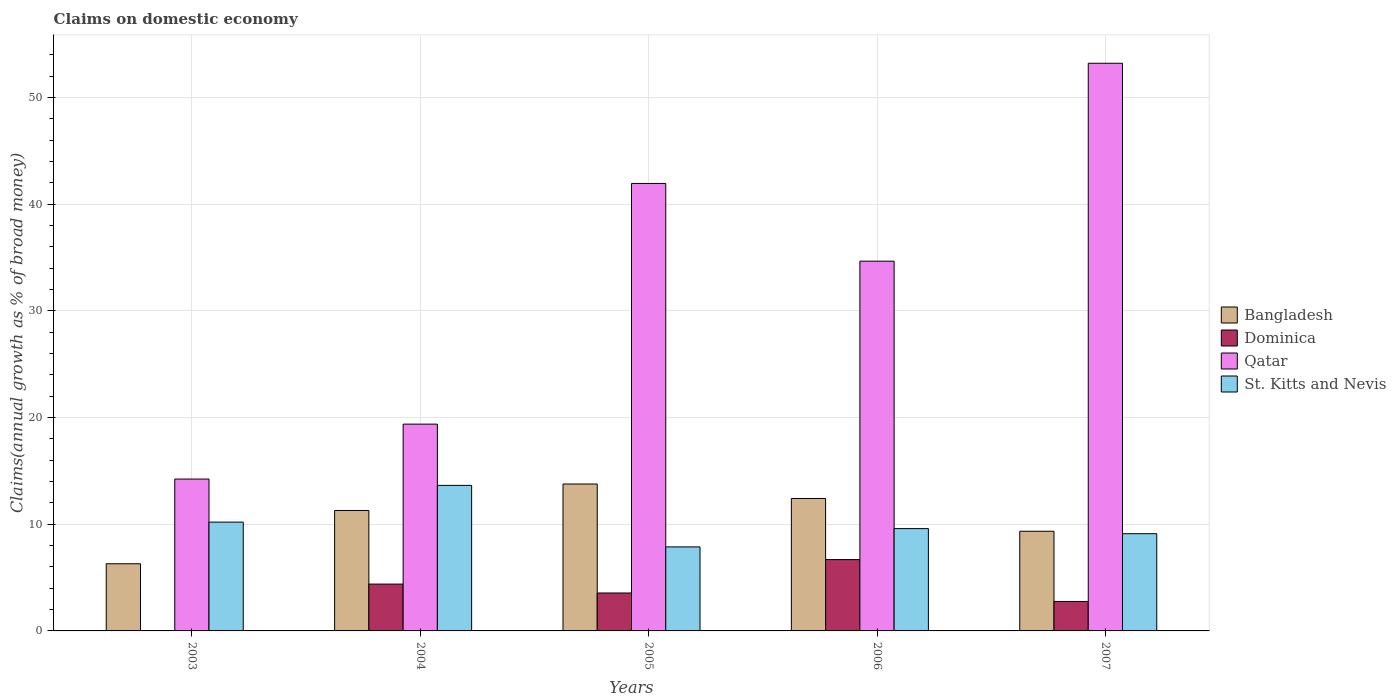How many different coloured bars are there?
Your answer should be compact. 4. How many groups of bars are there?
Provide a succinct answer. 5. Are the number of bars on each tick of the X-axis equal?
Your answer should be very brief. No. How many bars are there on the 1st tick from the left?
Keep it short and to the point. 3. How many bars are there on the 5th tick from the right?
Give a very brief answer. 3. Across all years, what is the maximum percentage of broad money claimed on domestic economy in Qatar?
Your answer should be compact. 53.22. Across all years, what is the minimum percentage of broad money claimed on domestic economy in Qatar?
Offer a very short reply. 14.24. In which year was the percentage of broad money claimed on domestic economy in Qatar maximum?
Your answer should be compact. 2007. What is the total percentage of broad money claimed on domestic economy in St. Kitts and Nevis in the graph?
Offer a very short reply. 50.43. What is the difference between the percentage of broad money claimed on domestic economy in Bangladesh in 2005 and that in 2007?
Ensure brevity in your answer.  4.43. What is the difference between the percentage of broad money claimed on domestic economy in Dominica in 2005 and the percentage of broad money claimed on domestic economy in Bangladesh in 2006?
Your response must be concise. -8.86. What is the average percentage of broad money claimed on domestic economy in Dominica per year?
Keep it short and to the point. 3.48. In the year 2007, what is the difference between the percentage of broad money claimed on domestic economy in Qatar and percentage of broad money claimed on domestic economy in Dominica?
Your response must be concise. 50.46. What is the ratio of the percentage of broad money claimed on domestic economy in Bangladesh in 2004 to that in 2006?
Your response must be concise. 0.91. What is the difference between the highest and the second highest percentage of broad money claimed on domestic economy in St. Kitts and Nevis?
Your answer should be compact. 3.44. What is the difference between the highest and the lowest percentage of broad money claimed on domestic economy in Bangladesh?
Provide a short and direct response. 7.48. Is it the case that in every year, the sum of the percentage of broad money claimed on domestic economy in Qatar and percentage of broad money claimed on domestic economy in Bangladesh is greater than the sum of percentage of broad money claimed on domestic economy in St. Kitts and Nevis and percentage of broad money claimed on domestic economy in Dominica?
Offer a terse response. Yes. Is it the case that in every year, the sum of the percentage of broad money claimed on domestic economy in St. Kitts and Nevis and percentage of broad money claimed on domestic economy in Bangladesh is greater than the percentage of broad money claimed on domestic economy in Qatar?
Your response must be concise. No. Are all the bars in the graph horizontal?
Provide a succinct answer. No. How many years are there in the graph?
Provide a short and direct response. 5. What is the difference between two consecutive major ticks on the Y-axis?
Give a very brief answer. 10. What is the title of the graph?
Your response must be concise. Claims on domestic economy. Does "Germany" appear as one of the legend labels in the graph?
Your response must be concise. No. What is the label or title of the Y-axis?
Your response must be concise. Claims(annual growth as % of broad money). What is the Claims(annual growth as % of broad money) in Bangladesh in 2003?
Make the answer very short. 6.3. What is the Claims(annual growth as % of broad money) in Dominica in 2003?
Provide a short and direct response. 0. What is the Claims(annual growth as % of broad money) of Qatar in 2003?
Your answer should be compact. 14.24. What is the Claims(annual growth as % of broad money) of St. Kitts and Nevis in 2003?
Give a very brief answer. 10.2. What is the Claims(annual growth as % of broad money) in Bangladesh in 2004?
Your answer should be very brief. 11.29. What is the Claims(annual growth as % of broad money) in Dominica in 2004?
Ensure brevity in your answer.  4.39. What is the Claims(annual growth as % of broad money) of Qatar in 2004?
Give a very brief answer. 19.39. What is the Claims(annual growth as % of broad money) of St. Kitts and Nevis in 2004?
Offer a very short reply. 13.65. What is the Claims(annual growth as % of broad money) of Bangladesh in 2005?
Provide a short and direct response. 13.77. What is the Claims(annual growth as % of broad money) of Dominica in 2005?
Offer a very short reply. 3.56. What is the Claims(annual growth as % of broad money) of Qatar in 2005?
Your answer should be very brief. 41.96. What is the Claims(annual growth as % of broad money) of St. Kitts and Nevis in 2005?
Your answer should be very brief. 7.88. What is the Claims(annual growth as % of broad money) in Bangladesh in 2006?
Offer a very short reply. 12.42. What is the Claims(annual growth as % of broad money) in Dominica in 2006?
Offer a very short reply. 6.69. What is the Claims(annual growth as % of broad money) in Qatar in 2006?
Ensure brevity in your answer.  34.67. What is the Claims(annual growth as % of broad money) of St. Kitts and Nevis in 2006?
Provide a succinct answer. 9.59. What is the Claims(annual growth as % of broad money) of Bangladesh in 2007?
Keep it short and to the point. 9.34. What is the Claims(annual growth as % of broad money) of Dominica in 2007?
Keep it short and to the point. 2.76. What is the Claims(annual growth as % of broad money) of Qatar in 2007?
Your answer should be very brief. 53.22. What is the Claims(annual growth as % of broad money) of St. Kitts and Nevis in 2007?
Your answer should be very brief. 9.12. Across all years, what is the maximum Claims(annual growth as % of broad money) in Bangladesh?
Your answer should be very brief. 13.77. Across all years, what is the maximum Claims(annual growth as % of broad money) in Dominica?
Offer a very short reply. 6.69. Across all years, what is the maximum Claims(annual growth as % of broad money) of Qatar?
Ensure brevity in your answer.  53.22. Across all years, what is the maximum Claims(annual growth as % of broad money) in St. Kitts and Nevis?
Keep it short and to the point. 13.65. Across all years, what is the minimum Claims(annual growth as % of broad money) in Bangladesh?
Offer a very short reply. 6.3. Across all years, what is the minimum Claims(annual growth as % of broad money) in Qatar?
Keep it short and to the point. 14.24. Across all years, what is the minimum Claims(annual growth as % of broad money) of St. Kitts and Nevis?
Give a very brief answer. 7.88. What is the total Claims(annual growth as % of broad money) in Bangladesh in the graph?
Ensure brevity in your answer.  53.13. What is the total Claims(annual growth as % of broad money) of Dominica in the graph?
Ensure brevity in your answer.  17.4. What is the total Claims(annual growth as % of broad money) of Qatar in the graph?
Your answer should be very brief. 163.48. What is the total Claims(annual growth as % of broad money) of St. Kitts and Nevis in the graph?
Ensure brevity in your answer.  50.43. What is the difference between the Claims(annual growth as % of broad money) in Bangladesh in 2003 and that in 2004?
Provide a short and direct response. -5. What is the difference between the Claims(annual growth as % of broad money) of Qatar in 2003 and that in 2004?
Your response must be concise. -5.15. What is the difference between the Claims(annual growth as % of broad money) of St. Kitts and Nevis in 2003 and that in 2004?
Your answer should be compact. -3.44. What is the difference between the Claims(annual growth as % of broad money) of Bangladesh in 2003 and that in 2005?
Ensure brevity in your answer.  -7.48. What is the difference between the Claims(annual growth as % of broad money) in Qatar in 2003 and that in 2005?
Your answer should be compact. -27.72. What is the difference between the Claims(annual growth as % of broad money) in St. Kitts and Nevis in 2003 and that in 2005?
Provide a short and direct response. 2.32. What is the difference between the Claims(annual growth as % of broad money) in Bangladesh in 2003 and that in 2006?
Provide a succinct answer. -6.12. What is the difference between the Claims(annual growth as % of broad money) of Qatar in 2003 and that in 2006?
Provide a succinct answer. -20.43. What is the difference between the Claims(annual growth as % of broad money) of St. Kitts and Nevis in 2003 and that in 2006?
Offer a terse response. 0.61. What is the difference between the Claims(annual growth as % of broad money) of Bangladesh in 2003 and that in 2007?
Provide a succinct answer. -3.05. What is the difference between the Claims(annual growth as % of broad money) in Qatar in 2003 and that in 2007?
Provide a short and direct response. -38.98. What is the difference between the Claims(annual growth as % of broad money) in St. Kitts and Nevis in 2003 and that in 2007?
Your response must be concise. 1.09. What is the difference between the Claims(annual growth as % of broad money) in Bangladesh in 2004 and that in 2005?
Make the answer very short. -2.48. What is the difference between the Claims(annual growth as % of broad money) of Dominica in 2004 and that in 2005?
Offer a terse response. 0.83. What is the difference between the Claims(annual growth as % of broad money) in Qatar in 2004 and that in 2005?
Ensure brevity in your answer.  -22.57. What is the difference between the Claims(annual growth as % of broad money) of St. Kitts and Nevis in 2004 and that in 2005?
Make the answer very short. 5.77. What is the difference between the Claims(annual growth as % of broad money) in Bangladesh in 2004 and that in 2006?
Your answer should be very brief. -1.13. What is the difference between the Claims(annual growth as % of broad money) in Dominica in 2004 and that in 2006?
Make the answer very short. -2.3. What is the difference between the Claims(annual growth as % of broad money) of Qatar in 2004 and that in 2006?
Provide a short and direct response. -15.28. What is the difference between the Claims(annual growth as % of broad money) in St. Kitts and Nevis in 2004 and that in 2006?
Your response must be concise. 4.05. What is the difference between the Claims(annual growth as % of broad money) in Bangladesh in 2004 and that in 2007?
Ensure brevity in your answer.  1.95. What is the difference between the Claims(annual growth as % of broad money) in Dominica in 2004 and that in 2007?
Provide a short and direct response. 1.63. What is the difference between the Claims(annual growth as % of broad money) of Qatar in 2004 and that in 2007?
Your answer should be compact. -33.84. What is the difference between the Claims(annual growth as % of broad money) of St. Kitts and Nevis in 2004 and that in 2007?
Your answer should be very brief. 4.53. What is the difference between the Claims(annual growth as % of broad money) of Bangladesh in 2005 and that in 2006?
Your response must be concise. 1.36. What is the difference between the Claims(annual growth as % of broad money) in Dominica in 2005 and that in 2006?
Offer a very short reply. -3.13. What is the difference between the Claims(annual growth as % of broad money) of Qatar in 2005 and that in 2006?
Give a very brief answer. 7.29. What is the difference between the Claims(annual growth as % of broad money) of St. Kitts and Nevis in 2005 and that in 2006?
Give a very brief answer. -1.71. What is the difference between the Claims(annual growth as % of broad money) of Bangladesh in 2005 and that in 2007?
Keep it short and to the point. 4.43. What is the difference between the Claims(annual growth as % of broad money) in Dominica in 2005 and that in 2007?
Provide a short and direct response. 0.8. What is the difference between the Claims(annual growth as % of broad money) of Qatar in 2005 and that in 2007?
Ensure brevity in your answer.  -11.27. What is the difference between the Claims(annual growth as % of broad money) in St. Kitts and Nevis in 2005 and that in 2007?
Your response must be concise. -1.24. What is the difference between the Claims(annual growth as % of broad money) of Bangladesh in 2006 and that in 2007?
Your answer should be compact. 3.07. What is the difference between the Claims(annual growth as % of broad money) of Dominica in 2006 and that in 2007?
Your response must be concise. 3.93. What is the difference between the Claims(annual growth as % of broad money) of Qatar in 2006 and that in 2007?
Your response must be concise. -18.56. What is the difference between the Claims(annual growth as % of broad money) in St. Kitts and Nevis in 2006 and that in 2007?
Offer a very short reply. 0.47. What is the difference between the Claims(annual growth as % of broad money) in Bangladesh in 2003 and the Claims(annual growth as % of broad money) in Dominica in 2004?
Keep it short and to the point. 1.91. What is the difference between the Claims(annual growth as % of broad money) in Bangladesh in 2003 and the Claims(annual growth as % of broad money) in Qatar in 2004?
Provide a short and direct response. -13.09. What is the difference between the Claims(annual growth as % of broad money) in Bangladesh in 2003 and the Claims(annual growth as % of broad money) in St. Kitts and Nevis in 2004?
Make the answer very short. -7.35. What is the difference between the Claims(annual growth as % of broad money) of Qatar in 2003 and the Claims(annual growth as % of broad money) of St. Kitts and Nevis in 2004?
Keep it short and to the point. 0.6. What is the difference between the Claims(annual growth as % of broad money) in Bangladesh in 2003 and the Claims(annual growth as % of broad money) in Dominica in 2005?
Offer a terse response. 2.74. What is the difference between the Claims(annual growth as % of broad money) of Bangladesh in 2003 and the Claims(annual growth as % of broad money) of Qatar in 2005?
Keep it short and to the point. -35.66. What is the difference between the Claims(annual growth as % of broad money) of Bangladesh in 2003 and the Claims(annual growth as % of broad money) of St. Kitts and Nevis in 2005?
Your answer should be very brief. -1.58. What is the difference between the Claims(annual growth as % of broad money) of Qatar in 2003 and the Claims(annual growth as % of broad money) of St. Kitts and Nevis in 2005?
Provide a succinct answer. 6.36. What is the difference between the Claims(annual growth as % of broad money) in Bangladesh in 2003 and the Claims(annual growth as % of broad money) in Dominica in 2006?
Ensure brevity in your answer.  -0.39. What is the difference between the Claims(annual growth as % of broad money) of Bangladesh in 2003 and the Claims(annual growth as % of broad money) of Qatar in 2006?
Provide a short and direct response. -28.37. What is the difference between the Claims(annual growth as % of broad money) of Bangladesh in 2003 and the Claims(annual growth as % of broad money) of St. Kitts and Nevis in 2006?
Provide a short and direct response. -3.29. What is the difference between the Claims(annual growth as % of broad money) of Qatar in 2003 and the Claims(annual growth as % of broad money) of St. Kitts and Nevis in 2006?
Your response must be concise. 4.65. What is the difference between the Claims(annual growth as % of broad money) of Bangladesh in 2003 and the Claims(annual growth as % of broad money) of Dominica in 2007?
Your answer should be compact. 3.54. What is the difference between the Claims(annual growth as % of broad money) in Bangladesh in 2003 and the Claims(annual growth as % of broad money) in Qatar in 2007?
Offer a very short reply. -46.93. What is the difference between the Claims(annual growth as % of broad money) of Bangladesh in 2003 and the Claims(annual growth as % of broad money) of St. Kitts and Nevis in 2007?
Offer a terse response. -2.82. What is the difference between the Claims(annual growth as % of broad money) in Qatar in 2003 and the Claims(annual growth as % of broad money) in St. Kitts and Nevis in 2007?
Provide a succinct answer. 5.12. What is the difference between the Claims(annual growth as % of broad money) in Bangladesh in 2004 and the Claims(annual growth as % of broad money) in Dominica in 2005?
Your answer should be compact. 7.74. What is the difference between the Claims(annual growth as % of broad money) of Bangladesh in 2004 and the Claims(annual growth as % of broad money) of Qatar in 2005?
Keep it short and to the point. -30.66. What is the difference between the Claims(annual growth as % of broad money) of Bangladesh in 2004 and the Claims(annual growth as % of broad money) of St. Kitts and Nevis in 2005?
Ensure brevity in your answer.  3.41. What is the difference between the Claims(annual growth as % of broad money) in Dominica in 2004 and the Claims(annual growth as % of broad money) in Qatar in 2005?
Offer a terse response. -37.56. What is the difference between the Claims(annual growth as % of broad money) in Dominica in 2004 and the Claims(annual growth as % of broad money) in St. Kitts and Nevis in 2005?
Make the answer very short. -3.49. What is the difference between the Claims(annual growth as % of broad money) in Qatar in 2004 and the Claims(annual growth as % of broad money) in St. Kitts and Nevis in 2005?
Your answer should be compact. 11.51. What is the difference between the Claims(annual growth as % of broad money) in Bangladesh in 2004 and the Claims(annual growth as % of broad money) in Dominica in 2006?
Your answer should be very brief. 4.6. What is the difference between the Claims(annual growth as % of broad money) in Bangladesh in 2004 and the Claims(annual growth as % of broad money) in Qatar in 2006?
Ensure brevity in your answer.  -23.38. What is the difference between the Claims(annual growth as % of broad money) of Bangladesh in 2004 and the Claims(annual growth as % of broad money) of St. Kitts and Nevis in 2006?
Your answer should be very brief. 1.7. What is the difference between the Claims(annual growth as % of broad money) of Dominica in 2004 and the Claims(annual growth as % of broad money) of Qatar in 2006?
Make the answer very short. -30.28. What is the difference between the Claims(annual growth as % of broad money) of Dominica in 2004 and the Claims(annual growth as % of broad money) of St. Kitts and Nevis in 2006?
Make the answer very short. -5.2. What is the difference between the Claims(annual growth as % of broad money) in Qatar in 2004 and the Claims(annual growth as % of broad money) in St. Kitts and Nevis in 2006?
Provide a succinct answer. 9.8. What is the difference between the Claims(annual growth as % of broad money) of Bangladesh in 2004 and the Claims(annual growth as % of broad money) of Dominica in 2007?
Offer a very short reply. 8.53. What is the difference between the Claims(annual growth as % of broad money) of Bangladesh in 2004 and the Claims(annual growth as % of broad money) of Qatar in 2007?
Keep it short and to the point. -41.93. What is the difference between the Claims(annual growth as % of broad money) of Bangladesh in 2004 and the Claims(annual growth as % of broad money) of St. Kitts and Nevis in 2007?
Keep it short and to the point. 2.18. What is the difference between the Claims(annual growth as % of broad money) of Dominica in 2004 and the Claims(annual growth as % of broad money) of Qatar in 2007?
Offer a very short reply. -48.83. What is the difference between the Claims(annual growth as % of broad money) of Dominica in 2004 and the Claims(annual growth as % of broad money) of St. Kitts and Nevis in 2007?
Your answer should be compact. -4.73. What is the difference between the Claims(annual growth as % of broad money) in Qatar in 2004 and the Claims(annual growth as % of broad money) in St. Kitts and Nevis in 2007?
Give a very brief answer. 10.27. What is the difference between the Claims(annual growth as % of broad money) of Bangladesh in 2005 and the Claims(annual growth as % of broad money) of Dominica in 2006?
Ensure brevity in your answer.  7.09. What is the difference between the Claims(annual growth as % of broad money) of Bangladesh in 2005 and the Claims(annual growth as % of broad money) of Qatar in 2006?
Make the answer very short. -20.89. What is the difference between the Claims(annual growth as % of broad money) of Bangladesh in 2005 and the Claims(annual growth as % of broad money) of St. Kitts and Nevis in 2006?
Offer a terse response. 4.18. What is the difference between the Claims(annual growth as % of broad money) in Dominica in 2005 and the Claims(annual growth as % of broad money) in Qatar in 2006?
Your answer should be compact. -31.11. What is the difference between the Claims(annual growth as % of broad money) of Dominica in 2005 and the Claims(annual growth as % of broad money) of St. Kitts and Nevis in 2006?
Your response must be concise. -6.03. What is the difference between the Claims(annual growth as % of broad money) of Qatar in 2005 and the Claims(annual growth as % of broad money) of St. Kitts and Nevis in 2006?
Make the answer very short. 32.36. What is the difference between the Claims(annual growth as % of broad money) in Bangladesh in 2005 and the Claims(annual growth as % of broad money) in Dominica in 2007?
Provide a short and direct response. 11.01. What is the difference between the Claims(annual growth as % of broad money) of Bangladesh in 2005 and the Claims(annual growth as % of broad money) of Qatar in 2007?
Give a very brief answer. -39.45. What is the difference between the Claims(annual growth as % of broad money) of Bangladesh in 2005 and the Claims(annual growth as % of broad money) of St. Kitts and Nevis in 2007?
Your answer should be very brief. 4.66. What is the difference between the Claims(annual growth as % of broad money) in Dominica in 2005 and the Claims(annual growth as % of broad money) in Qatar in 2007?
Offer a terse response. -49.67. What is the difference between the Claims(annual growth as % of broad money) of Dominica in 2005 and the Claims(annual growth as % of broad money) of St. Kitts and Nevis in 2007?
Keep it short and to the point. -5.56. What is the difference between the Claims(annual growth as % of broad money) of Qatar in 2005 and the Claims(annual growth as % of broad money) of St. Kitts and Nevis in 2007?
Your answer should be very brief. 32.84. What is the difference between the Claims(annual growth as % of broad money) in Bangladesh in 2006 and the Claims(annual growth as % of broad money) in Dominica in 2007?
Provide a succinct answer. 9.66. What is the difference between the Claims(annual growth as % of broad money) in Bangladesh in 2006 and the Claims(annual growth as % of broad money) in Qatar in 2007?
Provide a succinct answer. -40.81. What is the difference between the Claims(annual growth as % of broad money) of Bangladesh in 2006 and the Claims(annual growth as % of broad money) of St. Kitts and Nevis in 2007?
Your answer should be compact. 3.3. What is the difference between the Claims(annual growth as % of broad money) of Dominica in 2006 and the Claims(annual growth as % of broad money) of Qatar in 2007?
Your answer should be compact. -46.54. What is the difference between the Claims(annual growth as % of broad money) of Dominica in 2006 and the Claims(annual growth as % of broad money) of St. Kitts and Nevis in 2007?
Your response must be concise. -2.43. What is the difference between the Claims(annual growth as % of broad money) in Qatar in 2006 and the Claims(annual growth as % of broad money) in St. Kitts and Nevis in 2007?
Your answer should be very brief. 25.55. What is the average Claims(annual growth as % of broad money) in Bangladesh per year?
Your answer should be compact. 10.63. What is the average Claims(annual growth as % of broad money) in Dominica per year?
Offer a terse response. 3.48. What is the average Claims(annual growth as % of broad money) of Qatar per year?
Your response must be concise. 32.7. What is the average Claims(annual growth as % of broad money) in St. Kitts and Nevis per year?
Your answer should be compact. 10.09. In the year 2003, what is the difference between the Claims(annual growth as % of broad money) of Bangladesh and Claims(annual growth as % of broad money) of Qatar?
Your answer should be compact. -7.94. In the year 2003, what is the difference between the Claims(annual growth as % of broad money) of Bangladesh and Claims(annual growth as % of broad money) of St. Kitts and Nevis?
Give a very brief answer. -3.9. In the year 2003, what is the difference between the Claims(annual growth as % of broad money) in Qatar and Claims(annual growth as % of broad money) in St. Kitts and Nevis?
Your answer should be compact. 4.04. In the year 2004, what is the difference between the Claims(annual growth as % of broad money) in Bangladesh and Claims(annual growth as % of broad money) in Dominica?
Ensure brevity in your answer.  6.9. In the year 2004, what is the difference between the Claims(annual growth as % of broad money) in Bangladesh and Claims(annual growth as % of broad money) in Qatar?
Your answer should be very brief. -8.1. In the year 2004, what is the difference between the Claims(annual growth as % of broad money) in Bangladesh and Claims(annual growth as % of broad money) in St. Kitts and Nevis?
Your response must be concise. -2.35. In the year 2004, what is the difference between the Claims(annual growth as % of broad money) of Dominica and Claims(annual growth as % of broad money) of Qatar?
Ensure brevity in your answer.  -15. In the year 2004, what is the difference between the Claims(annual growth as % of broad money) of Dominica and Claims(annual growth as % of broad money) of St. Kitts and Nevis?
Make the answer very short. -9.25. In the year 2004, what is the difference between the Claims(annual growth as % of broad money) of Qatar and Claims(annual growth as % of broad money) of St. Kitts and Nevis?
Give a very brief answer. 5.74. In the year 2005, what is the difference between the Claims(annual growth as % of broad money) of Bangladesh and Claims(annual growth as % of broad money) of Dominica?
Make the answer very short. 10.22. In the year 2005, what is the difference between the Claims(annual growth as % of broad money) in Bangladesh and Claims(annual growth as % of broad money) in Qatar?
Provide a short and direct response. -28.18. In the year 2005, what is the difference between the Claims(annual growth as % of broad money) in Bangladesh and Claims(annual growth as % of broad money) in St. Kitts and Nevis?
Offer a terse response. 5.9. In the year 2005, what is the difference between the Claims(annual growth as % of broad money) in Dominica and Claims(annual growth as % of broad money) in Qatar?
Provide a short and direct response. -38.4. In the year 2005, what is the difference between the Claims(annual growth as % of broad money) in Dominica and Claims(annual growth as % of broad money) in St. Kitts and Nevis?
Offer a terse response. -4.32. In the year 2005, what is the difference between the Claims(annual growth as % of broad money) in Qatar and Claims(annual growth as % of broad money) in St. Kitts and Nevis?
Your response must be concise. 34.08. In the year 2006, what is the difference between the Claims(annual growth as % of broad money) of Bangladesh and Claims(annual growth as % of broad money) of Dominica?
Provide a succinct answer. 5.73. In the year 2006, what is the difference between the Claims(annual growth as % of broad money) of Bangladesh and Claims(annual growth as % of broad money) of Qatar?
Your answer should be very brief. -22.25. In the year 2006, what is the difference between the Claims(annual growth as % of broad money) in Bangladesh and Claims(annual growth as % of broad money) in St. Kitts and Nevis?
Give a very brief answer. 2.83. In the year 2006, what is the difference between the Claims(annual growth as % of broad money) in Dominica and Claims(annual growth as % of broad money) in Qatar?
Your answer should be very brief. -27.98. In the year 2006, what is the difference between the Claims(annual growth as % of broad money) of Dominica and Claims(annual growth as % of broad money) of St. Kitts and Nevis?
Give a very brief answer. -2.9. In the year 2006, what is the difference between the Claims(annual growth as % of broad money) of Qatar and Claims(annual growth as % of broad money) of St. Kitts and Nevis?
Your answer should be very brief. 25.08. In the year 2007, what is the difference between the Claims(annual growth as % of broad money) of Bangladesh and Claims(annual growth as % of broad money) of Dominica?
Ensure brevity in your answer.  6.58. In the year 2007, what is the difference between the Claims(annual growth as % of broad money) in Bangladesh and Claims(annual growth as % of broad money) in Qatar?
Ensure brevity in your answer.  -43.88. In the year 2007, what is the difference between the Claims(annual growth as % of broad money) in Bangladesh and Claims(annual growth as % of broad money) in St. Kitts and Nevis?
Offer a terse response. 0.23. In the year 2007, what is the difference between the Claims(annual growth as % of broad money) in Dominica and Claims(annual growth as % of broad money) in Qatar?
Provide a succinct answer. -50.46. In the year 2007, what is the difference between the Claims(annual growth as % of broad money) of Dominica and Claims(annual growth as % of broad money) of St. Kitts and Nevis?
Give a very brief answer. -6.35. In the year 2007, what is the difference between the Claims(annual growth as % of broad money) of Qatar and Claims(annual growth as % of broad money) of St. Kitts and Nevis?
Provide a succinct answer. 44.11. What is the ratio of the Claims(annual growth as % of broad money) of Bangladesh in 2003 to that in 2004?
Ensure brevity in your answer.  0.56. What is the ratio of the Claims(annual growth as % of broad money) in Qatar in 2003 to that in 2004?
Provide a short and direct response. 0.73. What is the ratio of the Claims(annual growth as % of broad money) of St. Kitts and Nevis in 2003 to that in 2004?
Ensure brevity in your answer.  0.75. What is the ratio of the Claims(annual growth as % of broad money) in Bangladesh in 2003 to that in 2005?
Give a very brief answer. 0.46. What is the ratio of the Claims(annual growth as % of broad money) of Qatar in 2003 to that in 2005?
Give a very brief answer. 0.34. What is the ratio of the Claims(annual growth as % of broad money) in St. Kitts and Nevis in 2003 to that in 2005?
Offer a very short reply. 1.29. What is the ratio of the Claims(annual growth as % of broad money) of Bangladesh in 2003 to that in 2006?
Your answer should be compact. 0.51. What is the ratio of the Claims(annual growth as % of broad money) in Qatar in 2003 to that in 2006?
Offer a very short reply. 0.41. What is the ratio of the Claims(annual growth as % of broad money) of St. Kitts and Nevis in 2003 to that in 2006?
Offer a very short reply. 1.06. What is the ratio of the Claims(annual growth as % of broad money) in Bangladesh in 2003 to that in 2007?
Provide a succinct answer. 0.67. What is the ratio of the Claims(annual growth as % of broad money) in Qatar in 2003 to that in 2007?
Provide a succinct answer. 0.27. What is the ratio of the Claims(annual growth as % of broad money) in St. Kitts and Nevis in 2003 to that in 2007?
Provide a short and direct response. 1.12. What is the ratio of the Claims(annual growth as % of broad money) of Bangladesh in 2004 to that in 2005?
Keep it short and to the point. 0.82. What is the ratio of the Claims(annual growth as % of broad money) of Dominica in 2004 to that in 2005?
Your answer should be compact. 1.23. What is the ratio of the Claims(annual growth as % of broad money) in Qatar in 2004 to that in 2005?
Your response must be concise. 0.46. What is the ratio of the Claims(annual growth as % of broad money) in St. Kitts and Nevis in 2004 to that in 2005?
Provide a short and direct response. 1.73. What is the ratio of the Claims(annual growth as % of broad money) in Bangladesh in 2004 to that in 2006?
Your answer should be very brief. 0.91. What is the ratio of the Claims(annual growth as % of broad money) of Dominica in 2004 to that in 2006?
Your answer should be very brief. 0.66. What is the ratio of the Claims(annual growth as % of broad money) of Qatar in 2004 to that in 2006?
Make the answer very short. 0.56. What is the ratio of the Claims(annual growth as % of broad money) of St. Kitts and Nevis in 2004 to that in 2006?
Your answer should be compact. 1.42. What is the ratio of the Claims(annual growth as % of broad money) of Bangladesh in 2004 to that in 2007?
Give a very brief answer. 1.21. What is the ratio of the Claims(annual growth as % of broad money) in Dominica in 2004 to that in 2007?
Offer a terse response. 1.59. What is the ratio of the Claims(annual growth as % of broad money) of Qatar in 2004 to that in 2007?
Your response must be concise. 0.36. What is the ratio of the Claims(annual growth as % of broad money) of St. Kitts and Nevis in 2004 to that in 2007?
Keep it short and to the point. 1.5. What is the ratio of the Claims(annual growth as % of broad money) in Bangladesh in 2005 to that in 2006?
Give a very brief answer. 1.11. What is the ratio of the Claims(annual growth as % of broad money) in Dominica in 2005 to that in 2006?
Your response must be concise. 0.53. What is the ratio of the Claims(annual growth as % of broad money) in Qatar in 2005 to that in 2006?
Ensure brevity in your answer.  1.21. What is the ratio of the Claims(annual growth as % of broad money) of St. Kitts and Nevis in 2005 to that in 2006?
Ensure brevity in your answer.  0.82. What is the ratio of the Claims(annual growth as % of broad money) of Bangladesh in 2005 to that in 2007?
Give a very brief answer. 1.47. What is the ratio of the Claims(annual growth as % of broad money) of Dominica in 2005 to that in 2007?
Make the answer very short. 1.29. What is the ratio of the Claims(annual growth as % of broad money) in Qatar in 2005 to that in 2007?
Make the answer very short. 0.79. What is the ratio of the Claims(annual growth as % of broad money) in St. Kitts and Nevis in 2005 to that in 2007?
Your answer should be compact. 0.86. What is the ratio of the Claims(annual growth as % of broad money) in Bangladesh in 2006 to that in 2007?
Your answer should be very brief. 1.33. What is the ratio of the Claims(annual growth as % of broad money) in Dominica in 2006 to that in 2007?
Give a very brief answer. 2.42. What is the ratio of the Claims(annual growth as % of broad money) in Qatar in 2006 to that in 2007?
Your answer should be very brief. 0.65. What is the ratio of the Claims(annual growth as % of broad money) of St. Kitts and Nevis in 2006 to that in 2007?
Provide a succinct answer. 1.05. What is the difference between the highest and the second highest Claims(annual growth as % of broad money) in Bangladesh?
Your answer should be very brief. 1.36. What is the difference between the highest and the second highest Claims(annual growth as % of broad money) in Dominica?
Make the answer very short. 2.3. What is the difference between the highest and the second highest Claims(annual growth as % of broad money) of Qatar?
Make the answer very short. 11.27. What is the difference between the highest and the second highest Claims(annual growth as % of broad money) in St. Kitts and Nevis?
Your answer should be very brief. 3.44. What is the difference between the highest and the lowest Claims(annual growth as % of broad money) in Bangladesh?
Your answer should be compact. 7.48. What is the difference between the highest and the lowest Claims(annual growth as % of broad money) in Dominica?
Make the answer very short. 6.69. What is the difference between the highest and the lowest Claims(annual growth as % of broad money) of Qatar?
Ensure brevity in your answer.  38.98. What is the difference between the highest and the lowest Claims(annual growth as % of broad money) in St. Kitts and Nevis?
Your answer should be very brief. 5.77. 